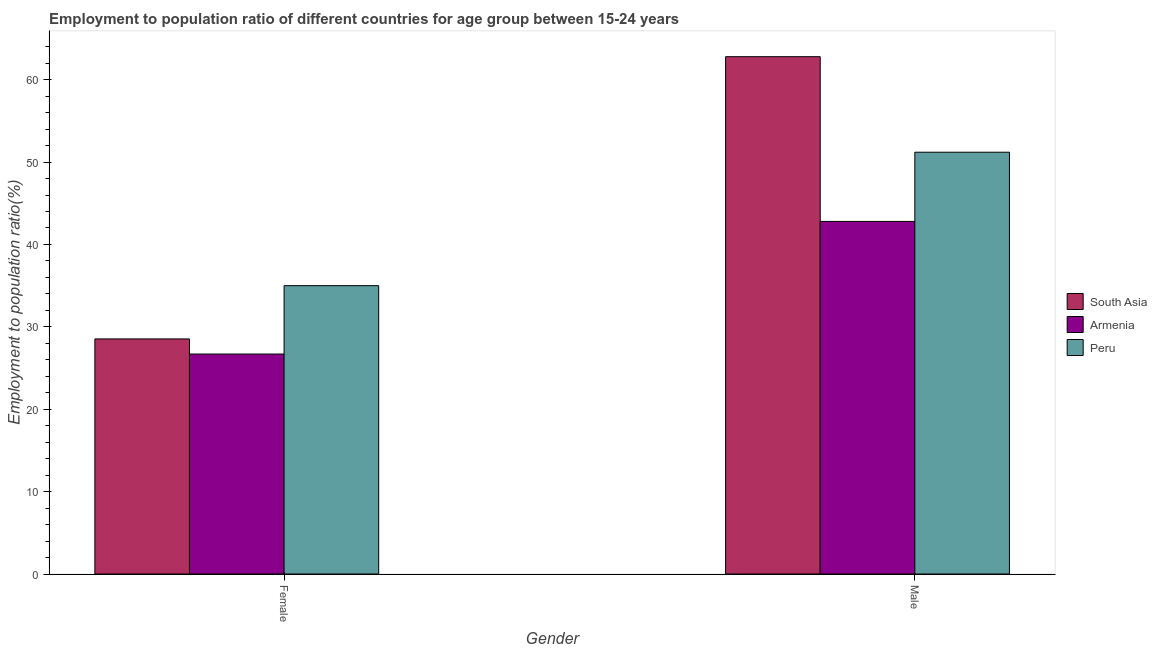How many groups of bars are there?
Your answer should be very brief. 2. Are the number of bars per tick equal to the number of legend labels?
Your response must be concise. Yes. What is the label of the 2nd group of bars from the left?
Your answer should be compact. Male. What is the employment to population ratio(female) in Peru?
Your response must be concise. 35. Across all countries, what is the maximum employment to population ratio(female)?
Give a very brief answer. 35. Across all countries, what is the minimum employment to population ratio(female)?
Your answer should be compact. 26.7. In which country was the employment to population ratio(female) maximum?
Keep it short and to the point. Peru. In which country was the employment to population ratio(female) minimum?
Keep it short and to the point. Armenia. What is the total employment to population ratio(female) in the graph?
Keep it short and to the point. 90.23. What is the difference between the employment to population ratio(female) in Armenia and that in South Asia?
Give a very brief answer. -1.83. What is the difference between the employment to population ratio(male) in Peru and the employment to population ratio(female) in South Asia?
Your response must be concise. 22.67. What is the average employment to population ratio(male) per country?
Make the answer very short. 52.26. What is the difference between the employment to population ratio(male) and employment to population ratio(female) in Peru?
Ensure brevity in your answer.  16.2. What is the ratio of the employment to population ratio(female) in Armenia to that in South Asia?
Provide a succinct answer. 0.94. In how many countries, is the employment to population ratio(male) greater than the average employment to population ratio(male) taken over all countries?
Offer a very short reply. 1. What does the 2nd bar from the left in Male represents?
Your response must be concise. Armenia. What does the 3rd bar from the right in Male represents?
Offer a terse response. South Asia. How many bars are there?
Offer a terse response. 6. How many countries are there in the graph?
Provide a succinct answer. 3. What is the difference between two consecutive major ticks on the Y-axis?
Ensure brevity in your answer.  10. Are the values on the major ticks of Y-axis written in scientific E-notation?
Your answer should be compact. No. Does the graph contain any zero values?
Provide a succinct answer. No. Where does the legend appear in the graph?
Keep it short and to the point. Center right. How are the legend labels stacked?
Keep it short and to the point. Vertical. What is the title of the graph?
Provide a short and direct response. Employment to population ratio of different countries for age group between 15-24 years. What is the label or title of the Y-axis?
Keep it short and to the point. Employment to population ratio(%). What is the Employment to population ratio(%) of South Asia in Female?
Your response must be concise. 28.53. What is the Employment to population ratio(%) of Armenia in Female?
Provide a short and direct response. 26.7. What is the Employment to population ratio(%) in Peru in Female?
Offer a very short reply. 35. What is the Employment to population ratio(%) in South Asia in Male?
Ensure brevity in your answer.  62.79. What is the Employment to population ratio(%) of Armenia in Male?
Provide a short and direct response. 42.8. What is the Employment to population ratio(%) in Peru in Male?
Provide a short and direct response. 51.2. Across all Gender, what is the maximum Employment to population ratio(%) of South Asia?
Provide a succinct answer. 62.79. Across all Gender, what is the maximum Employment to population ratio(%) in Armenia?
Offer a very short reply. 42.8. Across all Gender, what is the maximum Employment to population ratio(%) in Peru?
Your response must be concise. 51.2. Across all Gender, what is the minimum Employment to population ratio(%) in South Asia?
Your answer should be compact. 28.53. Across all Gender, what is the minimum Employment to population ratio(%) in Armenia?
Provide a succinct answer. 26.7. What is the total Employment to population ratio(%) in South Asia in the graph?
Provide a succinct answer. 91.33. What is the total Employment to population ratio(%) in Armenia in the graph?
Provide a succinct answer. 69.5. What is the total Employment to population ratio(%) of Peru in the graph?
Offer a terse response. 86.2. What is the difference between the Employment to population ratio(%) in South Asia in Female and that in Male?
Offer a very short reply. -34.26. What is the difference between the Employment to population ratio(%) in Armenia in Female and that in Male?
Keep it short and to the point. -16.1. What is the difference between the Employment to population ratio(%) in Peru in Female and that in Male?
Provide a short and direct response. -16.2. What is the difference between the Employment to population ratio(%) of South Asia in Female and the Employment to population ratio(%) of Armenia in Male?
Make the answer very short. -14.27. What is the difference between the Employment to population ratio(%) in South Asia in Female and the Employment to population ratio(%) in Peru in Male?
Make the answer very short. -22.66. What is the difference between the Employment to population ratio(%) in Armenia in Female and the Employment to population ratio(%) in Peru in Male?
Provide a short and direct response. -24.5. What is the average Employment to population ratio(%) of South Asia per Gender?
Your answer should be compact. 45.66. What is the average Employment to population ratio(%) in Armenia per Gender?
Your answer should be very brief. 34.75. What is the average Employment to population ratio(%) of Peru per Gender?
Offer a very short reply. 43.1. What is the difference between the Employment to population ratio(%) in South Asia and Employment to population ratio(%) in Armenia in Female?
Give a very brief answer. 1.83. What is the difference between the Employment to population ratio(%) of South Asia and Employment to population ratio(%) of Peru in Female?
Give a very brief answer. -6.46. What is the difference between the Employment to population ratio(%) of Armenia and Employment to population ratio(%) of Peru in Female?
Offer a very short reply. -8.3. What is the difference between the Employment to population ratio(%) in South Asia and Employment to population ratio(%) in Armenia in Male?
Keep it short and to the point. 19.99. What is the difference between the Employment to population ratio(%) in South Asia and Employment to population ratio(%) in Peru in Male?
Your answer should be very brief. 11.59. What is the ratio of the Employment to population ratio(%) of South Asia in Female to that in Male?
Make the answer very short. 0.45. What is the ratio of the Employment to population ratio(%) of Armenia in Female to that in Male?
Make the answer very short. 0.62. What is the ratio of the Employment to population ratio(%) in Peru in Female to that in Male?
Provide a succinct answer. 0.68. What is the difference between the highest and the second highest Employment to population ratio(%) of South Asia?
Give a very brief answer. 34.26. What is the difference between the highest and the second highest Employment to population ratio(%) in Armenia?
Your answer should be compact. 16.1. What is the difference between the highest and the second highest Employment to population ratio(%) in Peru?
Provide a short and direct response. 16.2. What is the difference between the highest and the lowest Employment to population ratio(%) of South Asia?
Keep it short and to the point. 34.26. 